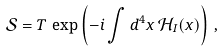Convert formula to latex. <formula><loc_0><loc_0><loc_500><loc_500>\mathcal { S } = T \, \exp \left ( - i \int d ^ { 4 } x \, \mathcal { H } _ { I } ( x ) \right ) \, ,</formula> 